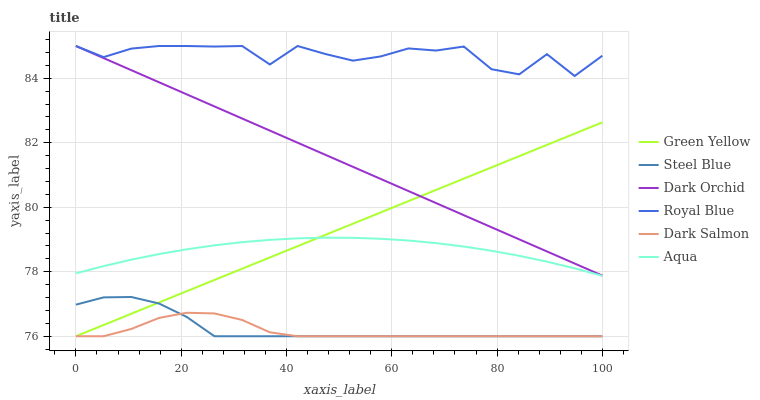Does Dark Salmon have the minimum area under the curve?
Answer yes or no. Yes. Does Royal Blue have the maximum area under the curve?
Answer yes or no. Yes. Does Steel Blue have the minimum area under the curve?
Answer yes or no. No. Does Steel Blue have the maximum area under the curve?
Answer yes or no. No. Is Green Yellow the smoothest?
Answer yes or no. Yes. Is Royal Blue the roughest?
Answer yes or no. Yes. Is Steel Blue the smoothest?
Answer yes or no. No. Is Steel Blue the roughest?
Answer yes or no. No. Does Steel Blue have the lowest value?
Answer yes or no. Yes. Does Dark Orchid have the lowest value?
Answer yes or no. No. Does Royal Blue have the highest value?
Answer yes or no. Yes. Does Steel Blue have the highest value?
Answer yes or no. No. Is Dark Salmon less than Dark Orchid?
Answer yes or no. Yes. Is Aqua greater than Dark Salmon?
Answer yes or no. Yes. Does Aqua intersect Green Yellow?
Answer yes or no. Yes. Is Aqua less than Green Yellow?
Answer yes or no. No. Is Aqua greater than Green Yellow?
Answer yes or no. No. Does Dark Salmon intersect Dark Orchid?
Answer yes or no. No. 